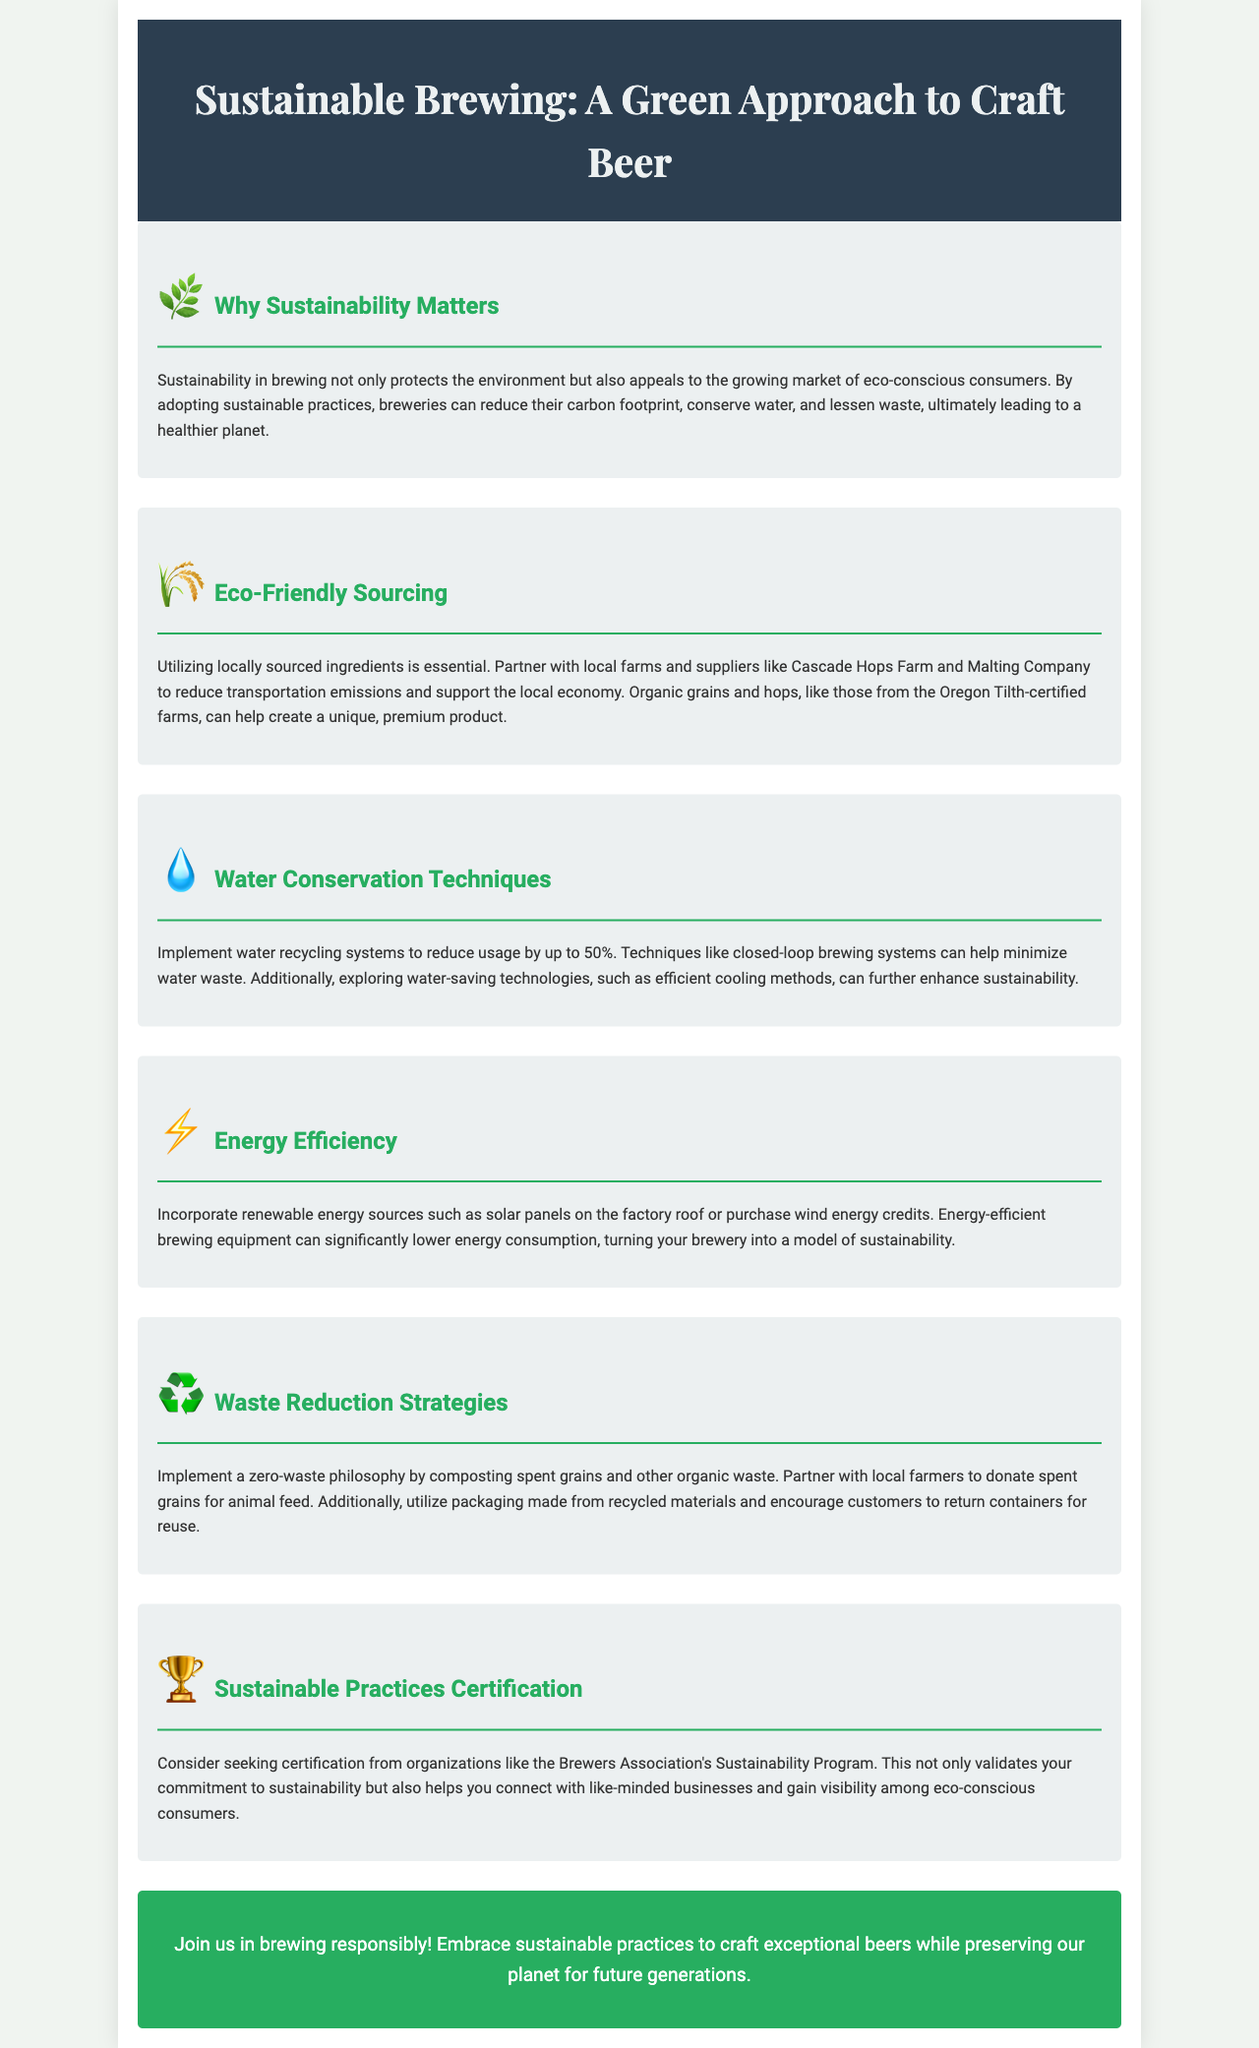What is the title of the brochure? The title of the brochure is prominently displayed at the top, indicating the theme of the content.
Answer: Sustainable Brewing: A Green Approach to Craft Beer What is one of the eco-friendly sourcing partners mentioned? The document lists specific partners to highlight local sourcing efforts.
Answer: Cascade Hops Farm How much can water recycling systems reduce water usage by? The document provides a quantitative estimate for potential water savings.
Answer: 50% What symbol represents energy efficiency in the brochure? There is an icon used in the document to represent energy-related practices.
Answer: ⚡ What is the waste philosophy mentioned in the waste reduction strategies? The brochure promotes a specific attitude towards waste management within the brewing process.
Answer: zero-waste Which organization’s certification is suggested for sustainability? The document references a particular organization associated with sustainability certification.
Answer: Brewers Association What is the main call to action in the brochure? The final section contains a motivational statement aimed at engaging readers.
Answer: Join us in brewing responsibly! What type of techniques does the document mention for water conservation? The text specifies certain methods to improve water efficiency in brewing.
Answer: closed-loop brewing systems What environmental benefit is highlighted in the "Why Sustainability Matters" section? The section addresses a key advantage of adopting sustainable practices in brewing.
Answer: healthier planet 